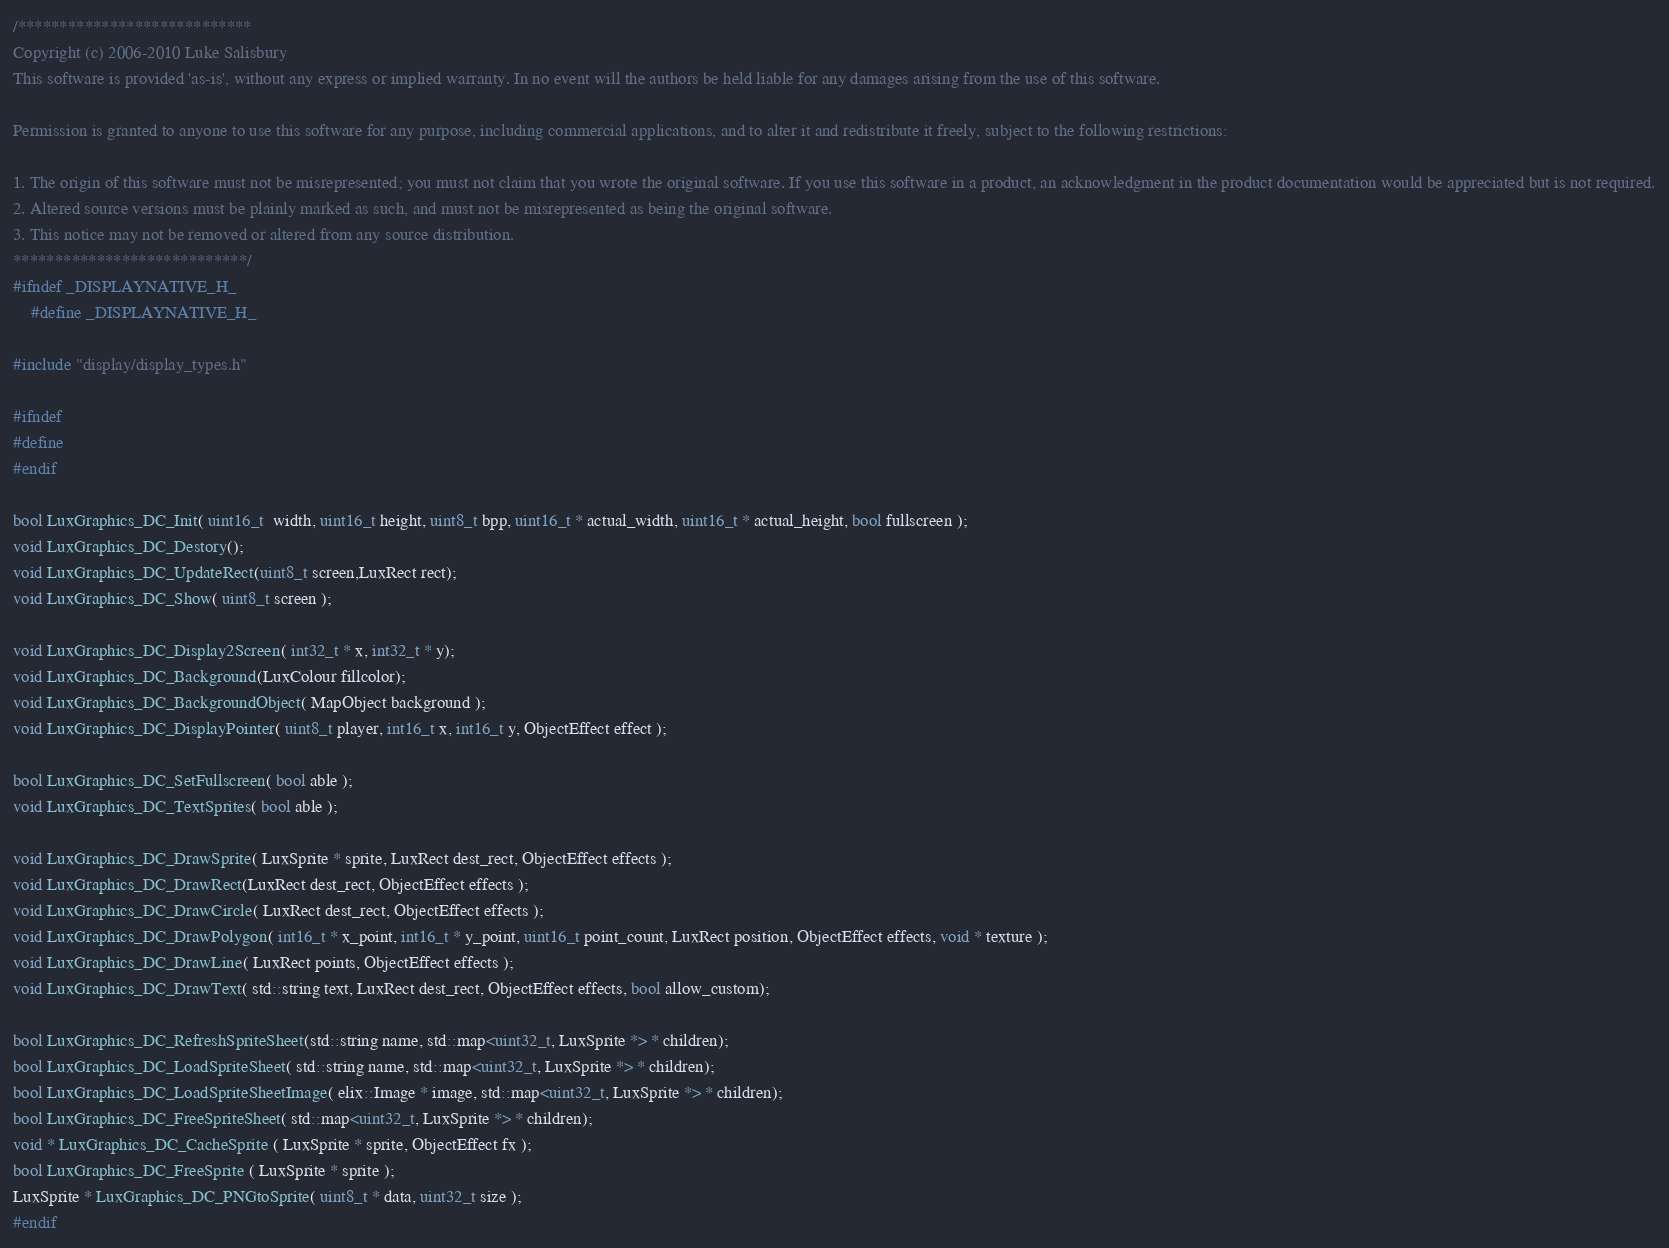<code> <loc_0><loc_0><loc_500><loc_500><_C_>/****************************
Copyright (c) 2006-2010 Luke Salisbury
This software is provided 'as-is', without any express or implied warranty. In no event will the authors be held liable for any damages arising from the use of this software.

Permission is granted to anyone to use this software for any purpose, including commercial applications, and to alter it and redistribute it freely, subject to the following restrictions:

1. The origin of this software must not be misrepresented; you must not claim that you wrote the original software. If you use this software in a product, an acknowledgment in the product documentation would be appreciated but is not required.
2. Altered source versions must be plainly marked as such, and must not be misrepresented as being the original software.
3. This notice may not be removed or altered from any source distribution.
****************************/
#ifndef _DISPLAYNATIVE_H_
	#define _DISPLAYNATIVE_H_

#include "display/display_types.h"

#ifndef 
#define 
#endif

bool LuxGraphics_DC_Init( uint16_t  width, uint16_t height, uint8_t bpp, uint16_t * actual_width, uint16_t * actual_height, bool fullscreen );
void LuxGraphics_DC_Destory();
void LuxGraphics_DC_UpdateRect(uint8_t screen,LuxRect rect);
void LuxGraphics_DC_Show( uint8_t screen );

void LuxGraphics_DC_Display2Screen( int32_t * x, int32_t * y);
void LuxGraphics_DC_Background(LuxColour fillcolor);
void LuxGraphics_DC_BackgroundObject( MapObject background );
void LuxGraphics_DC_DisplayPointer( uint8_t player, int16_t x, int16_t y, ObjectEffect effect );

bool LuxGraphics_DC_SetFullscreen( bool able );
void LuxGraphics_DC_TextSprites( bool able );

void LuxGraphics_DC_DrawSprite( LuxSprite * sprite, LuxRect dest_rect, ObjectEffect effects );
void LuxGraphics_DC_DrawRect(LuxRect dest_rect, ObjectEffect effects );
void LuxGraphics_DC_DrawCircle( LuxRect dest_rect, ObjectEffect effects );
void LuxGraphics_DC_DrawPolygon( int16_t * x_point, int16_t * y_point, uint16_t point_count, LuxRect position, ObjectEffect effects, void * texture );
void LuxGraphics_DC_DrawLine( LuxRect points, ObjectEffect effects );
void LuxGraphics_DC_DrawText( std::string text, LuxRect dest_rect, ObjectEffect effects, bool allow_custom);

bool LuxGraphics_DC_RefreshSpriteSheet(std::string name, std::map<uint32_t, LuxSprite *> * children);
bool LuxGraphics_DC_LoadSpriteSheet( std::string name, std::map<uint32_t, LuxSprite *> * children);
bool LuxGraphics_DC_LoadSpriteSheetImage( elix::Image * image, std::map<uint32_t, LuxSprite *> * children);
bool LuxGraphics_DC_FreeSpriteSheet( std::map<uint32_t, LuxSprite *> * children);
void * LuxGraphics_DC_CacheSprite ( LuxSprite * sprite, ObjectEffect fx );
bool LuxGraphics_DC_FreeSprite ( LuxSprite * sprite );
LuxSprite * LuxGraphics_DC_PNGtoSprite( uint8_t * data, uint32_t size );
#endif
</code> 